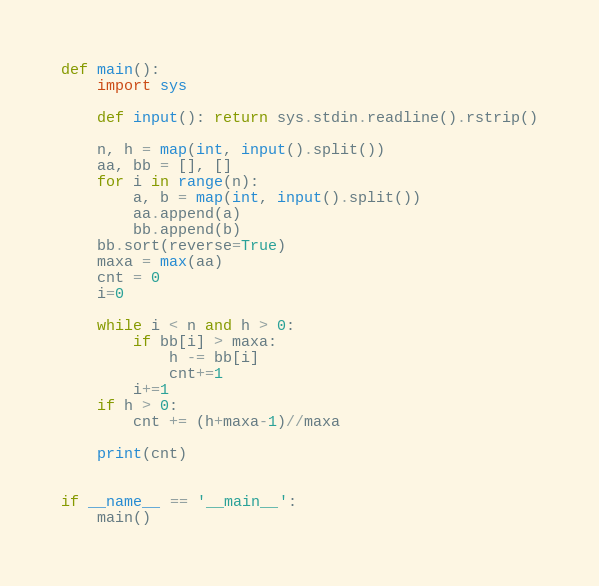<code> <loc_0><loc_0><loc_500><loc_500><_Python_>def main():
    import sys

    def input(): return sys.stdin.readline().rstrip()

    n, h = map(int, input().split())
    aa, bb = [], []
    for i in range(n):
        a, b = map(int, input().split())
        aa.append(a)
        bb.append(b)
    bb.sort(reverse=True)
    maxa = max(aa)
    cnt = 0
    i=0
    
    while i < n and h > 0:
        if bb[i] > maxa:
            h -= bb[i]
            cnt+=1
        i+=1
    if h > 0:
        cnt += (h+maxa-1)//maxa
        
    print(cnt)
        
        
if __name__ == '__main__':
    main()</code> 